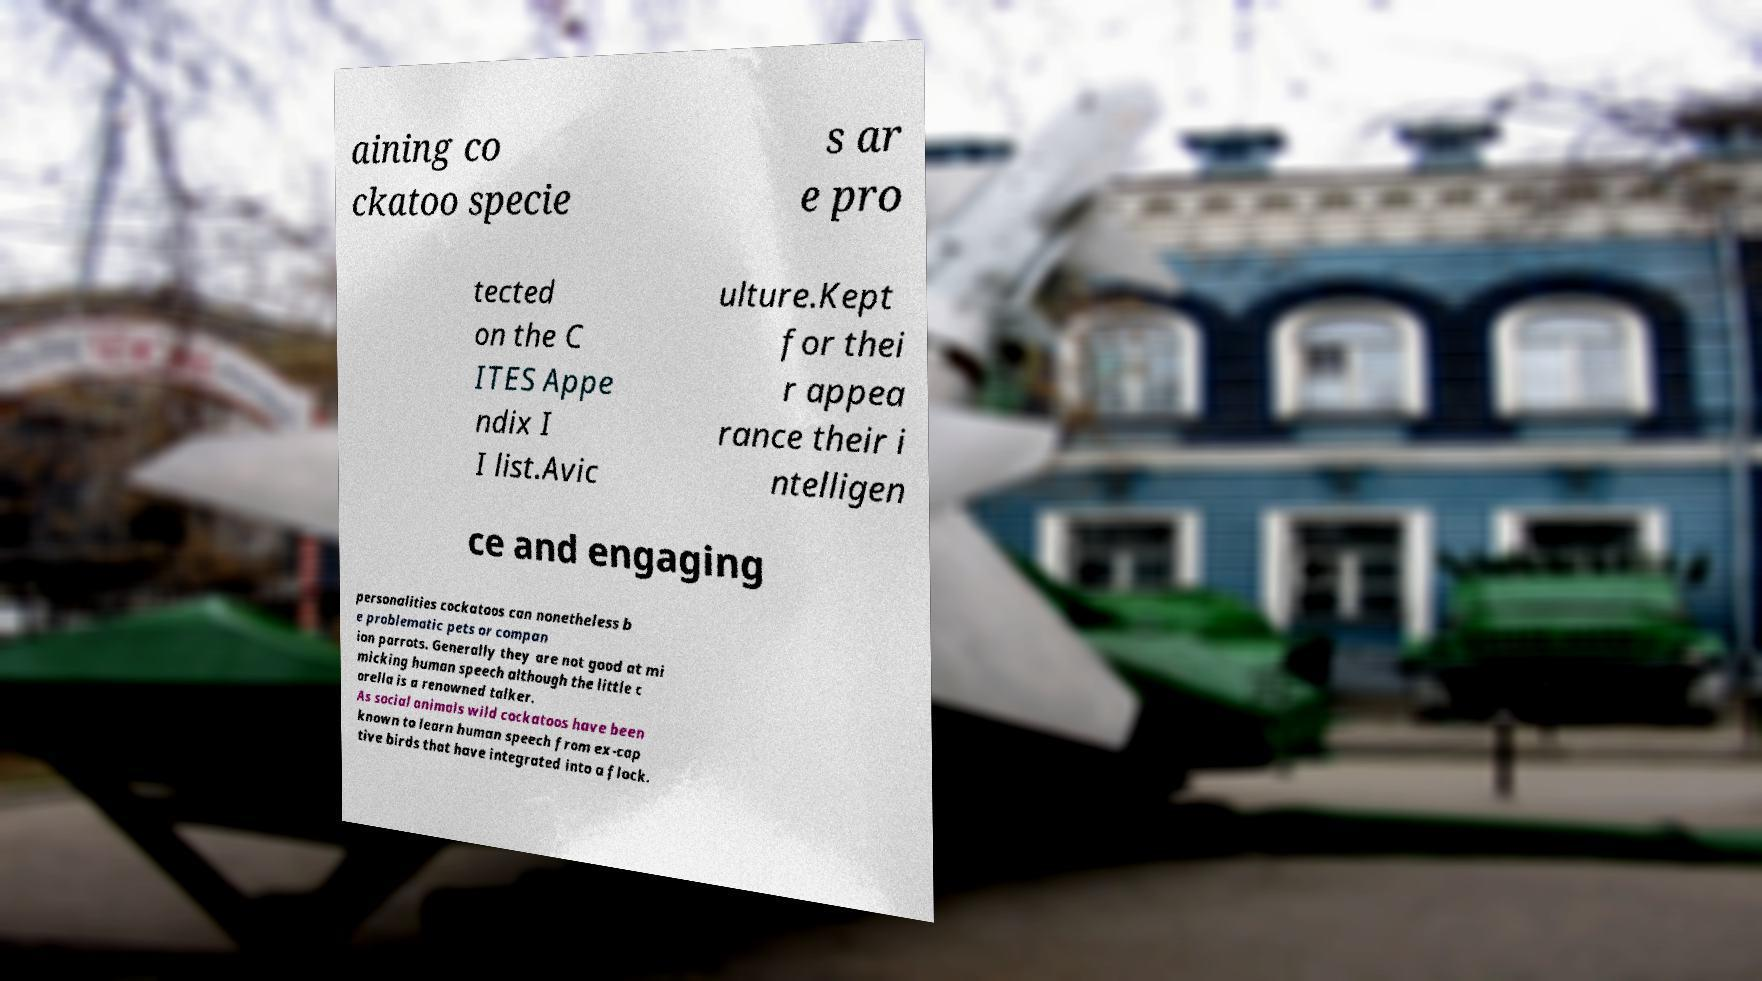Could you assist in decoding the text presented in this image and type it out clearly? aining co ckatoo specie s ar e pro tected on the C ITES Appe ndix I I list.Avic ulture.Kept for thei r appea rance their i ntelligen ce and engaging personalities cockatoos can nonetheless b e problematic pets or compan ion parrots. Generally they are not good at mi micking human speech although the little c orella is a renowned talker. As social animals wild cockatoos have been known to learn human speech from ex-cap tive birds that have integrated into a flock. 